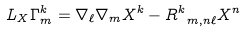<formula> <loc_0><loc_0><loc_500><loc_500>L _ { X } \Gamma ^ { k } _ { m } = \nabla _ { \ell } \nabla _ { m } X ^ { k } - R ^ { k } _ { \ m , n \ell } X ^ { n }</formula> 